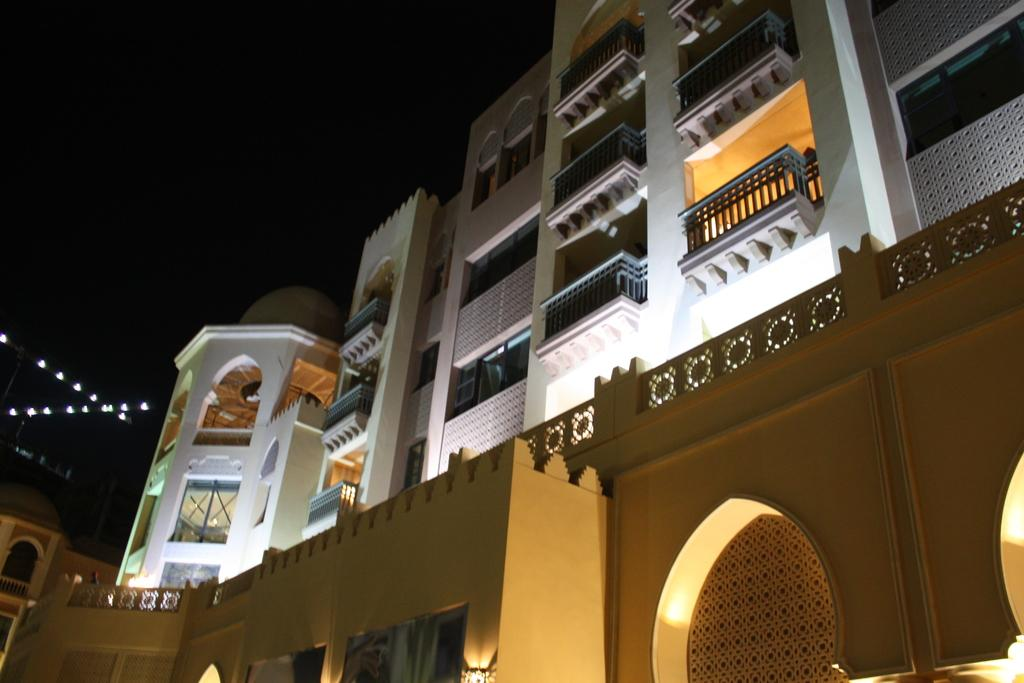What type of structures can be seen in the picture? There are buildings in the picture. What else can be seen in the picture besides the buildings? There are lights visible in the picture. How would you describe the sky in the background of the picture? The sky in the background is dark. What type of plot is being used for the tub in the image? There is no tub present in the image, so it is not possible to determine what type of plot might be used for it. 